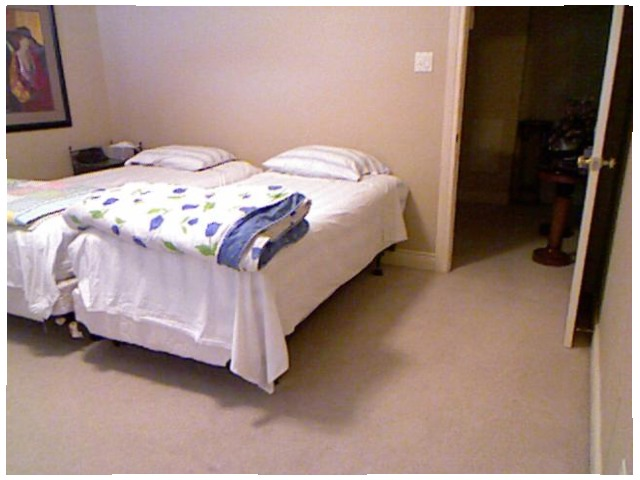<image>
Is the pillow on the bed? Yes. Looking at the image, I can see the pillow is positioned on top of the bed, with the bed providing support. Is the pillow next to the blanket? No. The pillow is not positioned next to the blanket. They are located in different areas of the scene. Is the table next to the bed? No. The table is not positioned next to the bed. They are located in different areas of the scene. 